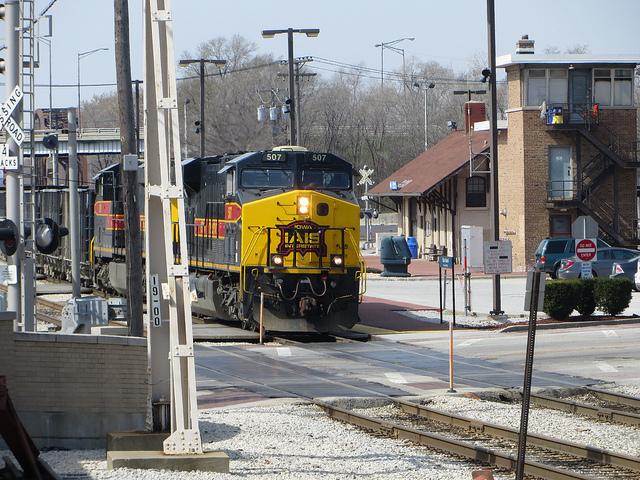From the signage, what country is this train from?
Be succinct. United states. What is the yellow vehicle?
Give a very brief answer. Train. Is it night time?
Answer briefly. No. 